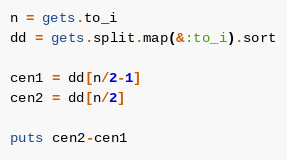<code> <loc_0><loc_0><loc_500><loc_500><_Ruby_>n = gets.to_i
dd = gets.split.map(&:to_i).sort

cen1 = dd[n/2-1]
cen2 = dd[n/2]

puts cen2-cen1</code> 